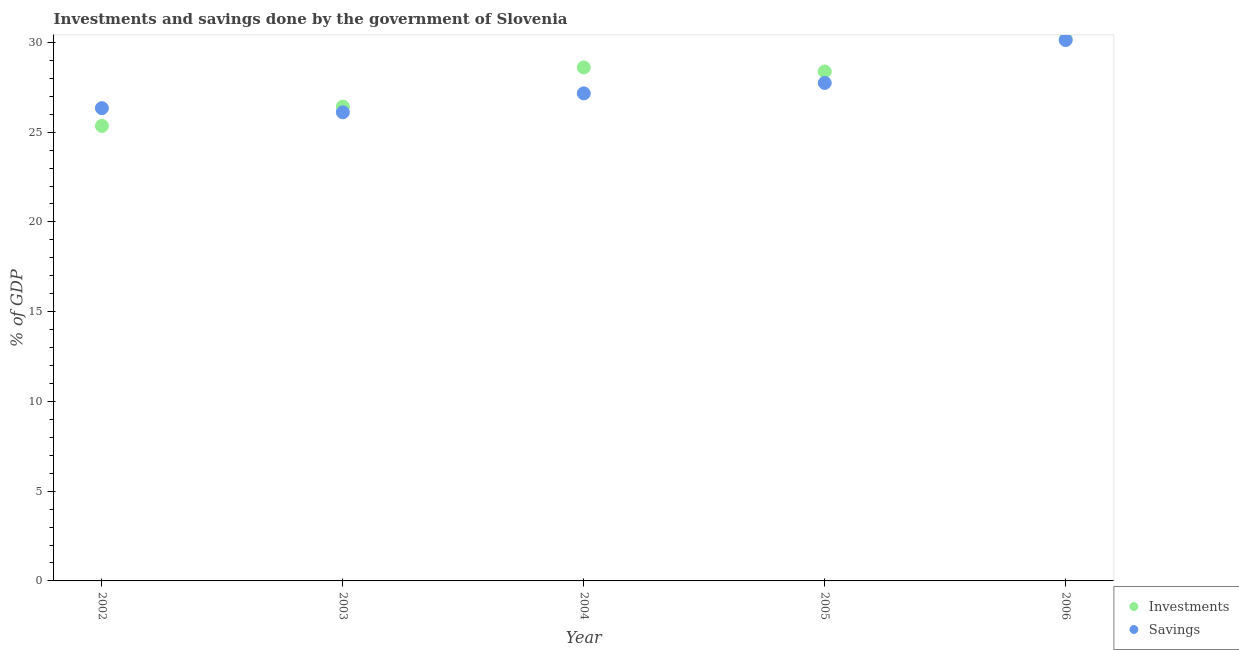How many different coloured dotlines are there?
Make the answer very short. 2. Is the number of dotlines equal to the number of legend labels?
Your response must be concise. Yes. What is the savings of government in 2003?
Provide a short and direct response. 26.11. Across all years, what is the maximum savings of government?
Offer a terse response. 30.13. Across all years, what is the minimum investments of government?
Your response must be concise. 25.35. In which year was the savings of government maximum?
Offer a terse response. 2006. In which year was the savings of government minimum?
Give a very brief answer. 2003. What is the total savings of government in the graph?
Give a very brief answer. 137.48. What is the difference between the savings of government in 2002 and that in 2006?
Offer a very short reply. -3.79. What is the difference between the investments of government in 2003 and the savings of government in 2006?
Your answer should be compact. -3.71. What is the average investments of government per year?
Keep it short and to the point. 27.79. In the year 2004, what is the difference between the investments of government and savings of government?
Offer a very short reply. 1.44. What is the ratio of the savings of government in 2002 to that in 2004?
Keep it short and to the point. 0.97. Is the investments of government in 2002 less than that in 2006?
Provide a succinct answer. Yes. Is the difference between the investments of government in 2002 and 2006 greater than the difference between the savings of government in 2002 and 2006?
Your answer should be very brief. No. What is the difference between the highest and the second highest investments of government?
Your answer should be very brief. 1.57. What is the difference between the highest and the lowest investments of government?
Give a very brief answer. 4.83. Is the sum of the investments of government in 2003 and 2006 greater than the maximum savings of government across all years?
Keep it short and to the point. Yes. Does the savings of government monotonically increase over the years?
Your answer should be compact. No. Is the savings of government strictly less than the investments of government over the years?
Your answer should be very brief. No. How many dotlines are there?
Your answer should be very brief. 2. How many years are there in the graph?
Your response must be concise. 5. Are the values on the major ticks of Y-axis written in scientific E-notation?
Make the answer very short. No. How many legend labels are there?
Provide a short and direct response. 2. What is the title of the graph?
Provide a short and direct response. Investments and savings done by the government of Slovenia. What is the label or title of the X-axis?
Give a very brief answer. Year. What is the label or title of the Y-axis?
Offer a very short reply. % of GDP. What is the % of GDP of Investments in 2002?
Keep it short and to the point. 25.35. What is the % of GDP in Savings in 2002?
Offer a terse response. 26.34. What is the % of GDP of Investments in 2003?
Ensure brevity in your answer.  26.42. What is the % of GDP of Savings in 2003?
Give a very brief answer. 26.11. What is the % of GDP in Investments in 2004?
Your answer should be compact. 28.61. What is the % of GDP of Savings in 2004?
Give a very brief answer. 27.16. What is the % of GDP in Investments in 2005?
Ensure brevity in your answer.  28.38. What is the % of GDP in Savings in 2005?
Provide a succinct answer. 27.74. What is the % of GDP of Investments in 2006?
Make the answer very short. 30.18. What is the % of GDP of Savings in 2006?
Your response must be concise. 30.13. Across all years, what is the maximum % of GDP of Investments?
Provide a short and direct response. 30.18. Across all years, what is the maximum % of GDP of Savings?
Give a very brief answer. 30.13. Across all years, what is the minimum % of GDP of Investments?
Your answer should be compact. 25.35. Across all years, what is the minimum % of GDP of Savings?
Keep it short and to the point. 26.11. What is the total % of GDP of Investments in the graph?
Provide a succinct answer. 138.93. What is the total % of GDP of Savings in the graph?
Provide a short and direct response. 137.48. What is the difference between the % of GDP of Investments in 2002 and that in 2003?
Provide a succinct answer. -1.07. What is the difference between the % of GDP in Savings in 2002 and that in 2003?
Provide a short and direct response. 0.23. What is the difference between the % of GDP in Investments in 2002 and that in 2004?
Offer a very short reply. -3.26. What is the difference between the % of GDP of Savings in 2002 and that in 2004?
Your answer should be very brief. -0.82. What is the difference between the % of GDP of Investments in 2002 and that in 2005?
Make the answer very short. -3.03. What is the difference between the % of GDP in Savings in 2002 and that in 2005?
Your answer should be very brief. -1.41. What is the difference between the % of GDP of Investments in 2002 and that in 2006?
Keep it short and to the point. -4.83. What is the difference between the % of GDP of Savings in 2002 and that in 2006?
Give a very brief answer. -3.79. What is the difference between the % of GDP in Investments in 2003 and that in 2004?
Offer a very short reply. -2.18. What is the difference between the % of GDP in Savings in 2003 and that in 2004?
Offer a terse response. -1.06. What is the difference between the % of GDP of Investments in 2003 and that in 2005?
Your answer should be very brief. -1.96. What is the difference between the % of GDP of Savings in 2003 and that in 2005?
Your answer should be compact. -1.64. What is the difference between the % of GDP of Investments in 2003 and that in 2006?
Make the answer very short. -3.76. What is the difference between the % of GDP of Savings in 2003 and that in 2006?
Provide a succinct answer. -4.02. What is the difference between the % of GDP of Investments in 2004 and that in 2005?
Make the answer very short. 0.23. What is the difference between the % of GDP in Savings in 2004 and that in 2005?
Keep it short and to the point. -0.58. What is the difference between the % of GDP in Investments in 2004 and that in 2006?
Ensure brevity in your answer.  -1.57. What is the difference between the % of GDP in Savings in 2004 and that in 2006?
Give a very brief answer. -2.97. What is the difference between the % of GDP in Investments in 2005 and that in 2006?
Your answer should be very brief. -1.8. What is the difference between the % of GDP of Savings in 2005 and that in 2006?
Give a very brief answer. -2.39. What is the difference between the % of GDP of Investments in 2002 and the % of GDP of Savings in 2003?
Your answer should be compact. -0.76. What is the difference between the % of GDP of Investments in 2002 and the % of GDP of Savings in 2004?
Give a very brief answer. -1.81. What is the difference between the % of GDP in Investments in 2002 and the % of GDP in Savings in 2005?
Make the answer very short. -2.39. What is the difference between the % of GDP of Investments in 2002 and the % of GDP of Savings in 2006?
Your response must be concise. -4.78. What is the difference between the % of GDP of Investments in 2003 and the % of GDP of Savings in 2004?
Make the answer very short. -0.74. What is the difference between the % of GDP in Investments in 2003 and the % of GDP in Savings in 2005?
Make the answer very short. -1.32. What is the difference between the % of GDP of Investments in 2003 and the % of GDP of Savings in 2006?
Your answer should be compact. -3.71. What is the difference between the % of GDP in Investments in 2004 and the % of GDP in Savings in 2005?
Offer a very short reply. 0.86. What is the difference between the % of GDP in Investments in 2004 and the % of GDP in Savings in 2006?
Offer a very short reply. -1.52. What is the difference between the % of GDP of Investments in 2005 and the % of GDP of Savings in 2006?
Provide a succinct answer. -1.75. What is the average % of GDP in Investments per year?
Make the answer very short. 27.79. What is the average % of GDP of Savings per year?
Keep it short and to the point. 27.5. In the year 2002, what is the difference between the % of GDP of Investments and % of GDP of Savings?
Give a very brief answer. -0.99. In the year 2003, what is the difference between the % of GDP of Investments and % of GDP of Savings?
Keep it short and to the point. 0.32. In the year 2004, what is the difference between the % of GDP of Investments and % of GDP of Savings?
Make the answer very short. 1.44. In the year 2005, what is the difference between the % of GDP in Investments and % of GDP in Savings?
Make the answer very short. 0.64. In the year 2006, what is the difference between the % of GDP of Investments and % of GDP of Savings?
Keep it short and to the point. 0.05. What is the ratio of the % of GDP of Investments in 2002 to that in 2003?
Give a very brief answer. 0.96. What is the ratio of the % of GDP of Savings in 2002 to that in 2003?
Provide a succinct answer. 1.01. What is the ratio of the % of GDP of Investments in 2002 to that in 2004?
Provide a succinct answer. 0.89. What is the ratio of the % of GDP in Savings in 2002 to that in 2004?
Your answer should be very brief. 0.97. What is the ratio of the % of GDP of Investments in 2002 to that in 2005?
Your response must be concise. 0.89. What is the ratio of the % of GDP in Savings in 2002 to that in 2005?
Give a very brief answer. 0.95. What is the ratio of the % of GDP in Investments in 2002 to that in 2006?
Your response must be concise. 0.84. What is the ratio of the % of GDP of Savings in 2002 to that in 2006?
Offer a very short reply. 0.87. What is the ratio of the % of GDP of Investments in 2003 to that in 2004?
Provide a succinct answer. 0.92. What is the ratio of the % of GDP in Savings in 2003 to that in 2004?
Offer a terse response. 0.96. What is the ratio of the % of GDP in Investments in 2003 to that in 2005?
Ensure brevity in your answer.  0.93. What is the ratio of the % of GDP of Savings in 2003 to that in 2005?
Keep it short and to the point. 0.94. What is the ratio of the % of GDP of Investments in 2003 to that in 2006?
Provide a succinct answer. 0.88. What is the ratio of the % of GDP in Savings in 2003 to that in 2006?
Your answer should be compact. 0.87. What is the ratio of the % of GDP in Investments in 2004 to that in 2005?
Ensure brevity in your answer.  1.01. What is the ratio of the % of GDP of Investments in 2004 to that in 2006?
Ensure brevity in your answer.  0.95. What is the ratio of the % of GDP in Savings in 2004 to that in 2006?
Give a very brief answer. 0.9. What is the ratio of the % of GDP in Investments in 2005 to that in 2006?
Ensure brevity in your answer.  0.94. What is the ratio of the % of GDP in Savings in 2005 to that in 2006?
Offer a terse response. 0.92. What is the difference between the highest and the second highest % of GDP of Investments?
Your answer should be compact. 1.57. What is the difference between the highest and the second highest % of GDP of Savings?
Offer a very short reply. 2.39. What is the difference between the highest and the lowest % of GDP in Investments?
Your answer should be compact. 4.83. What is the difference between the highest and the lowest % of GDP in Savings?
Keep it short and to the point. 4.02. 